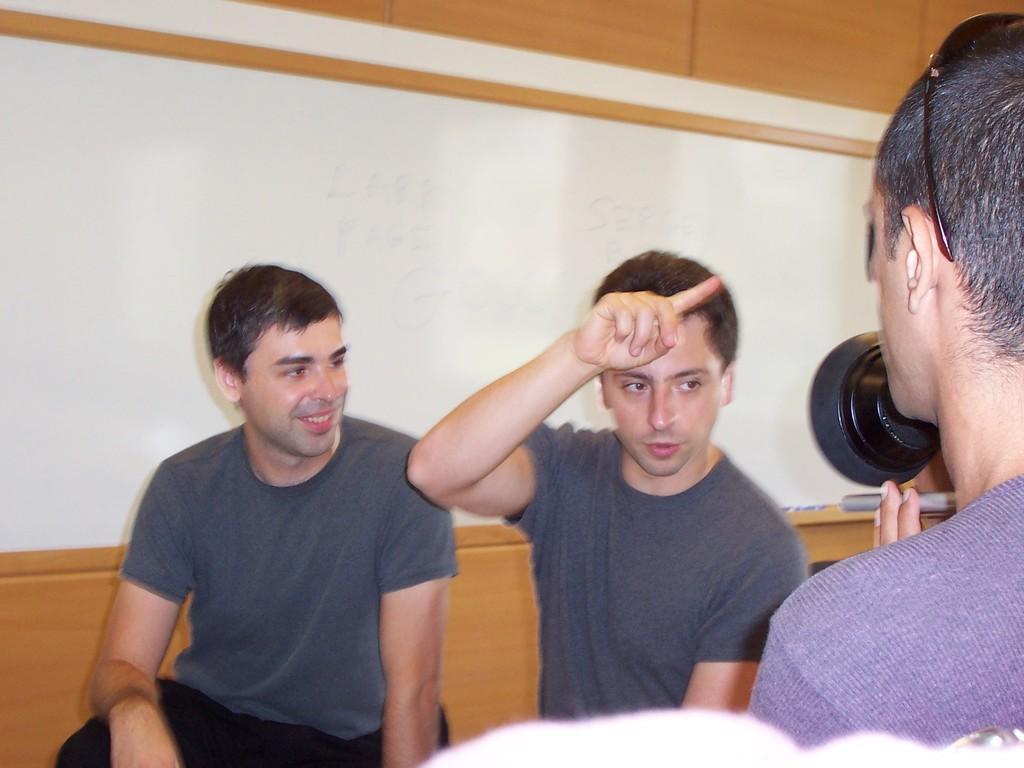In one or two sentences, can you explain what this image depicts? In this image, there are two men sitting. On the right side of the image, I can see another person holding an object in his hands. This looks like the wall. 